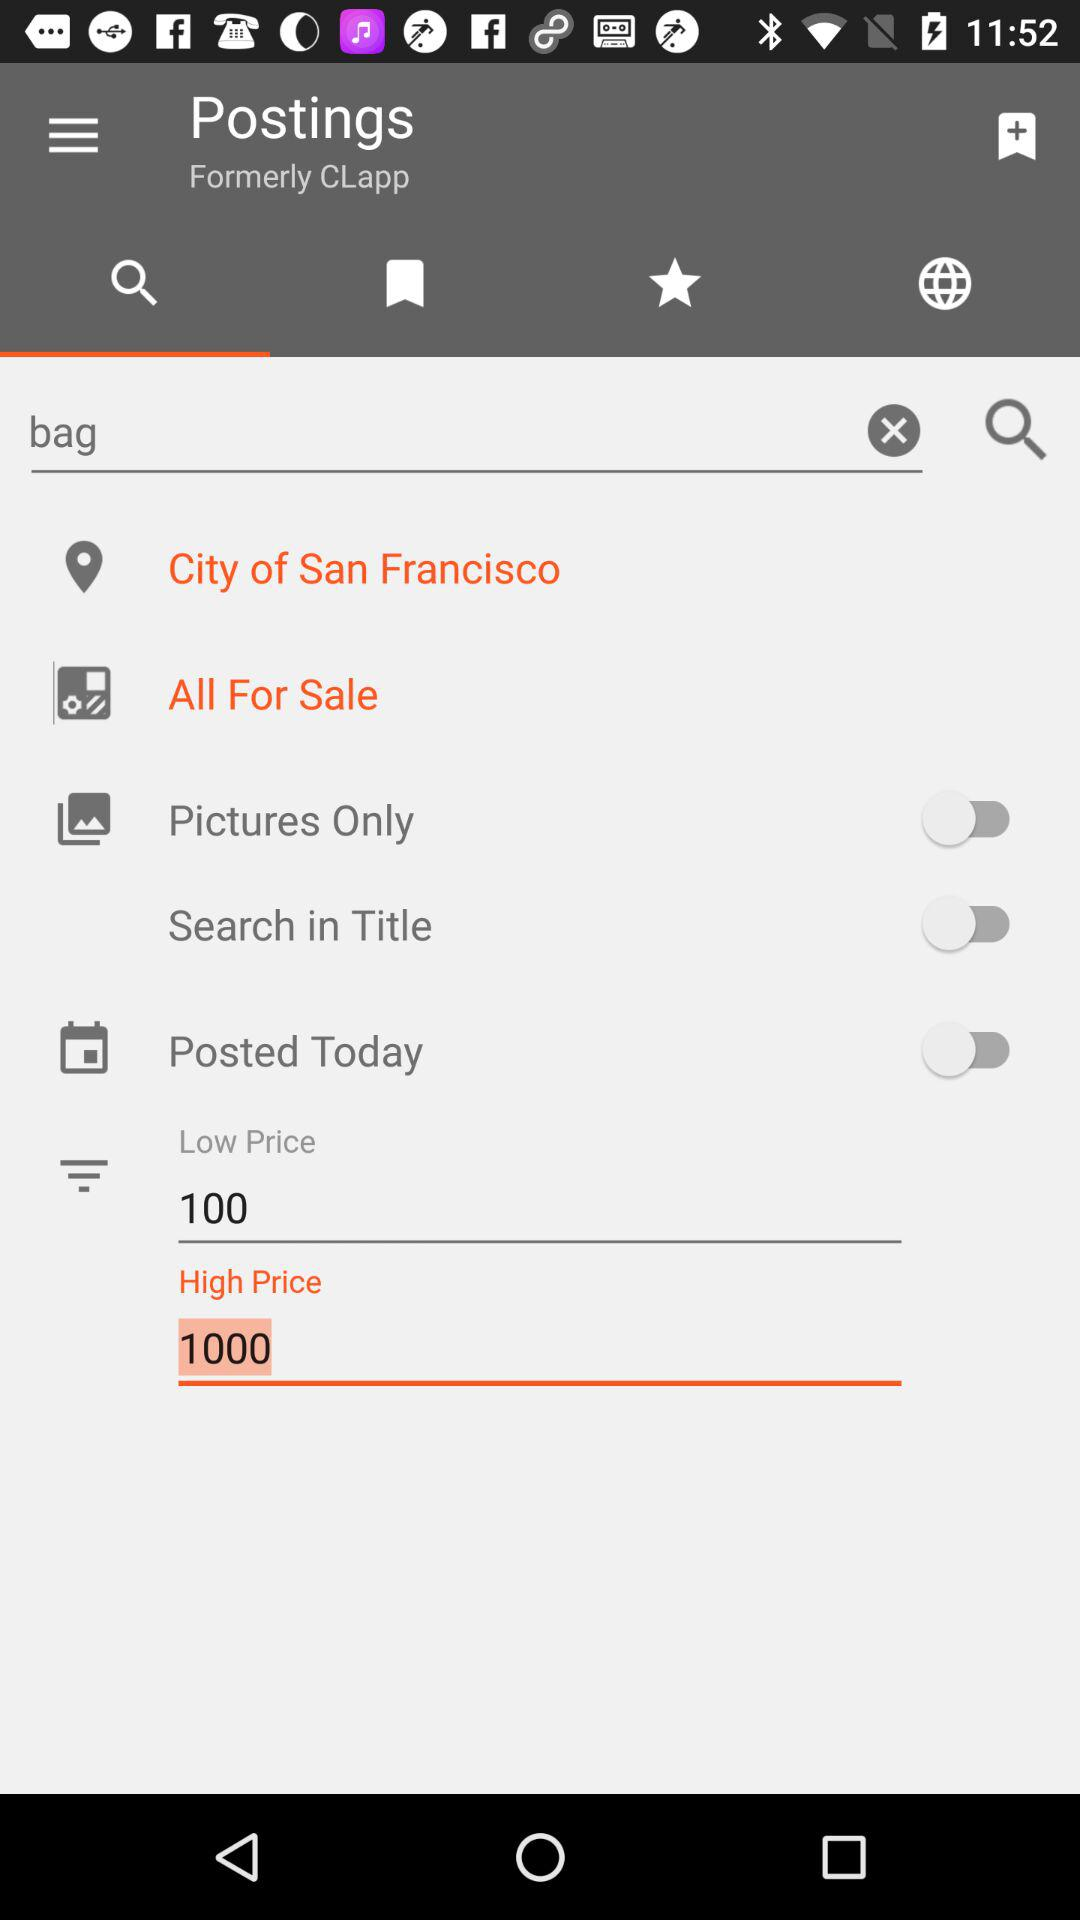What is the difference between the high price and the low price?
Answer the question using a single word or phrase. 900 